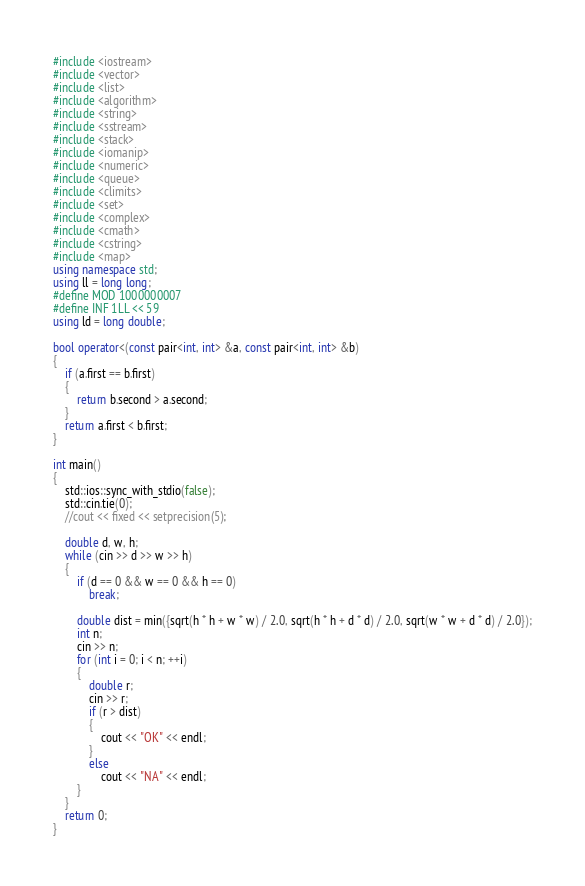Convert code to text. <code><loc_0><loc_0><loc_500><loc_500><_C++_>#include <iostream>
#include <vector>
#include <list>
#include <algorithm>
#include <string>
#include <sstream>
#include <stack>
#include <iomanip>
#include <numeric>
#include <queue>
#include <climits>
#include <set>
#include <complex>
#include <cmath>
#include <cstring>
#include <map>
using namespace std;
using ll = long long;
#define MOD 1000000007
#define INF 1LL << 59
using ld = long double;

bool operator<(const pair<int, int> &a, const pair<int, int> &b)
{
    if (a.first == b.first)
    {
        return b.second > a.second;
    }
    return a.first < b.first;
}

int main()
{
    std::ios::sync_with_stdio(false);
    std::cin.tie(0);
    //cout << fixed << setprecision(5);

    double d, w, h;
    while (cin >> d >> w >> h)
    {
        if (d == 0 && w == 0 && h == 0)
            break;

        double dist = min({sqrt(h * h + w * w) / 2.0, sqrt(h * h + d * d) / 2.0, sqrt(w * w + d * d) / 2.0});
        int n;
        cin >> n;
        for (int i = 0; i < n; ++i)
        {
            double r;
            cin >> r;
            if (r > dist)
            {
                cout << "OK" << endl;
            }
            else
                cout << "NA" << endl;
        }
    }
    return 0;
}
</code> 